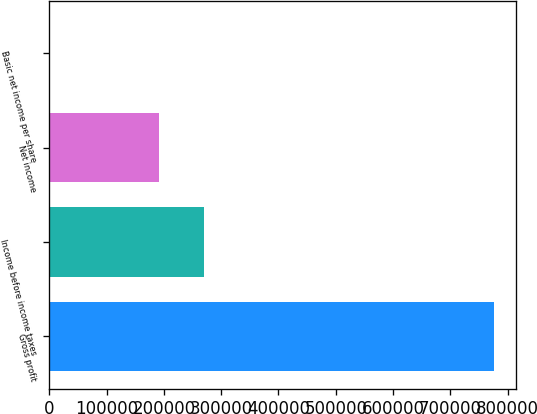Convert chart to OTSL. <chart><loc_0><loc_0><loc_500><loc_500><bar_chart><fcel>Gross profit<fcel>Income before income taxes<fcel>Net income<fcel>Basic net income per share<nl><fcel>776406<fcel>269249<fcel>191608<fcel>0.36<nl></chart> 